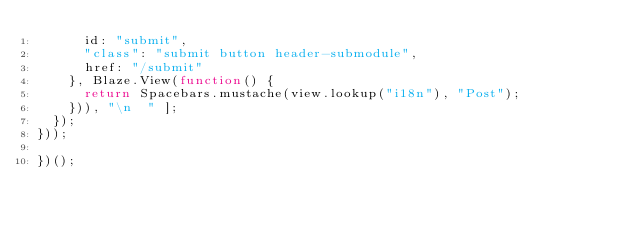<code> <loc_0><loc_0><loc_500><loc_500><_JavaScript_>      id: "submit",
      "class": "submit button header-submodule",
      href: "/submit"
    }, Blaze.View(function() {
      return Spacebars.mustache(view.lookup("i18n"), "Post");
    })), "\n  " ];
  });
}));

})();
</code> 